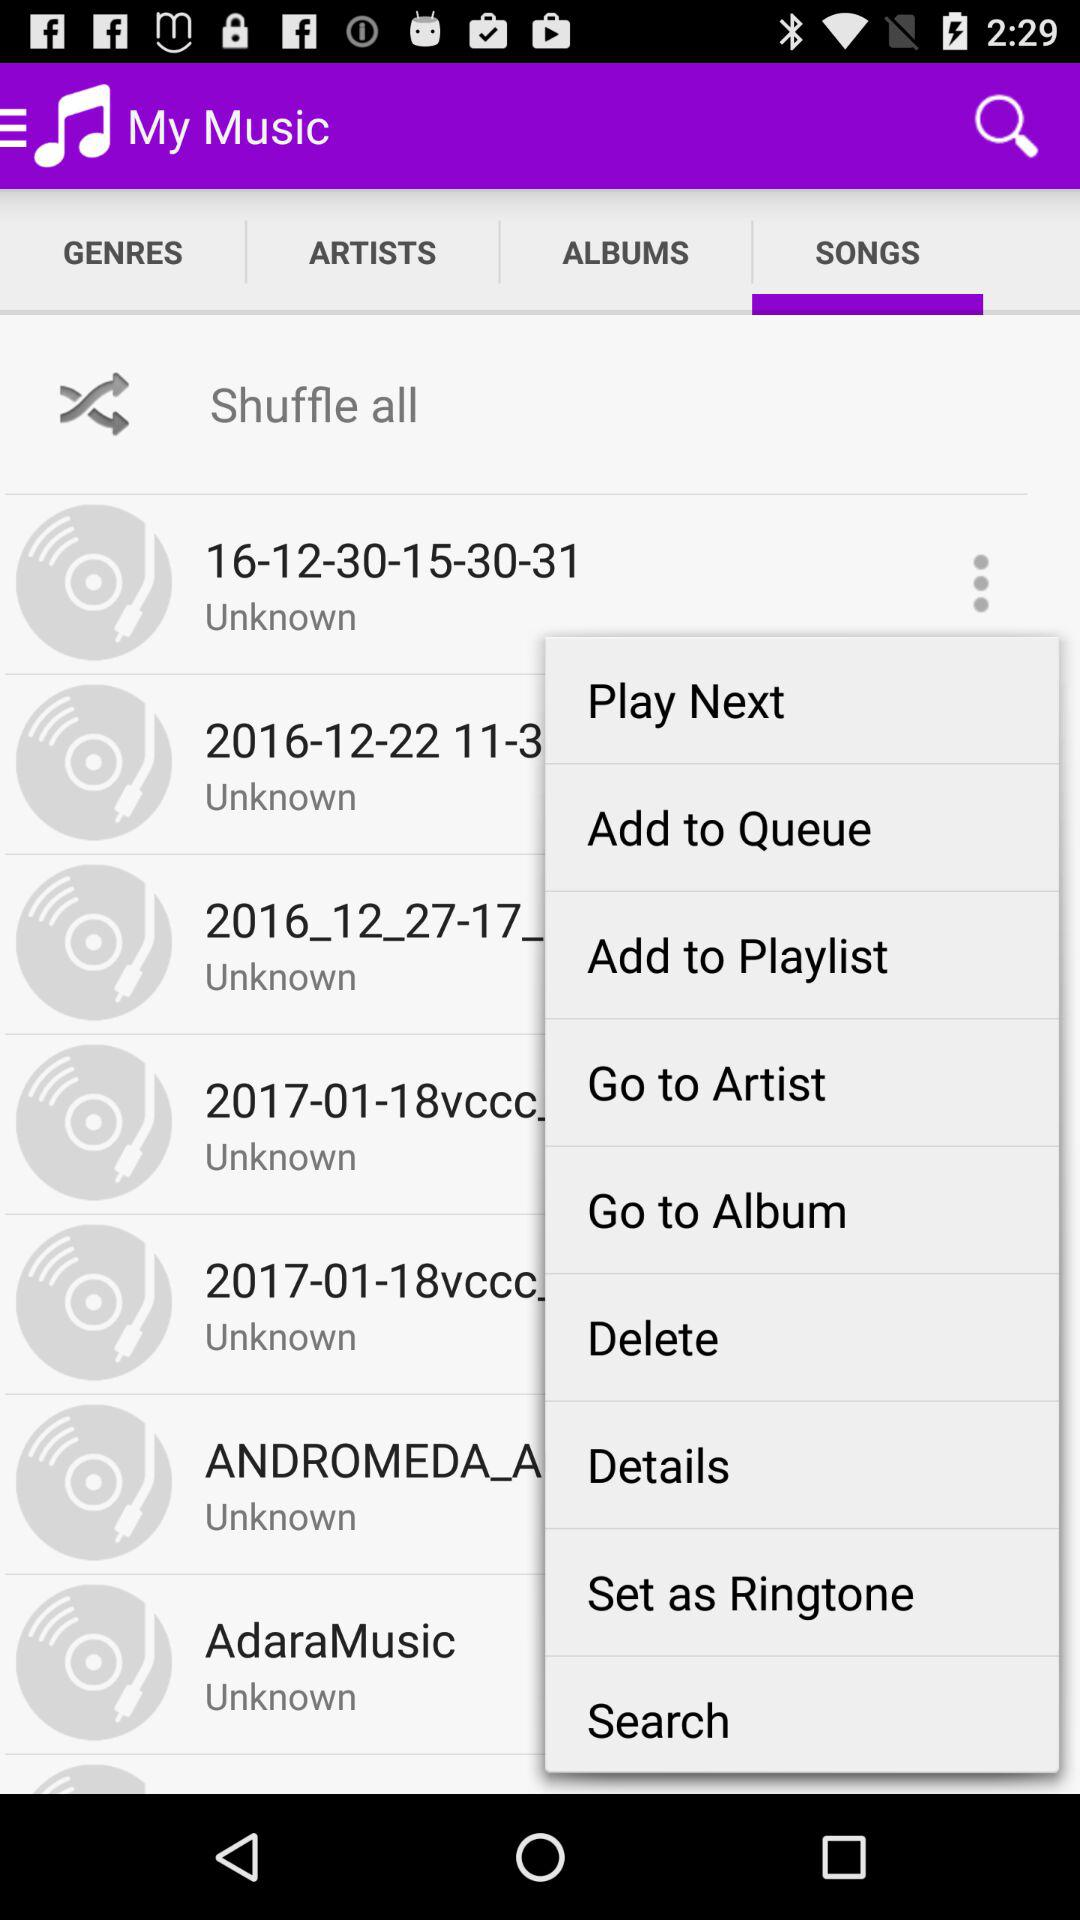Which tab is selected? The selected tab is songs. 